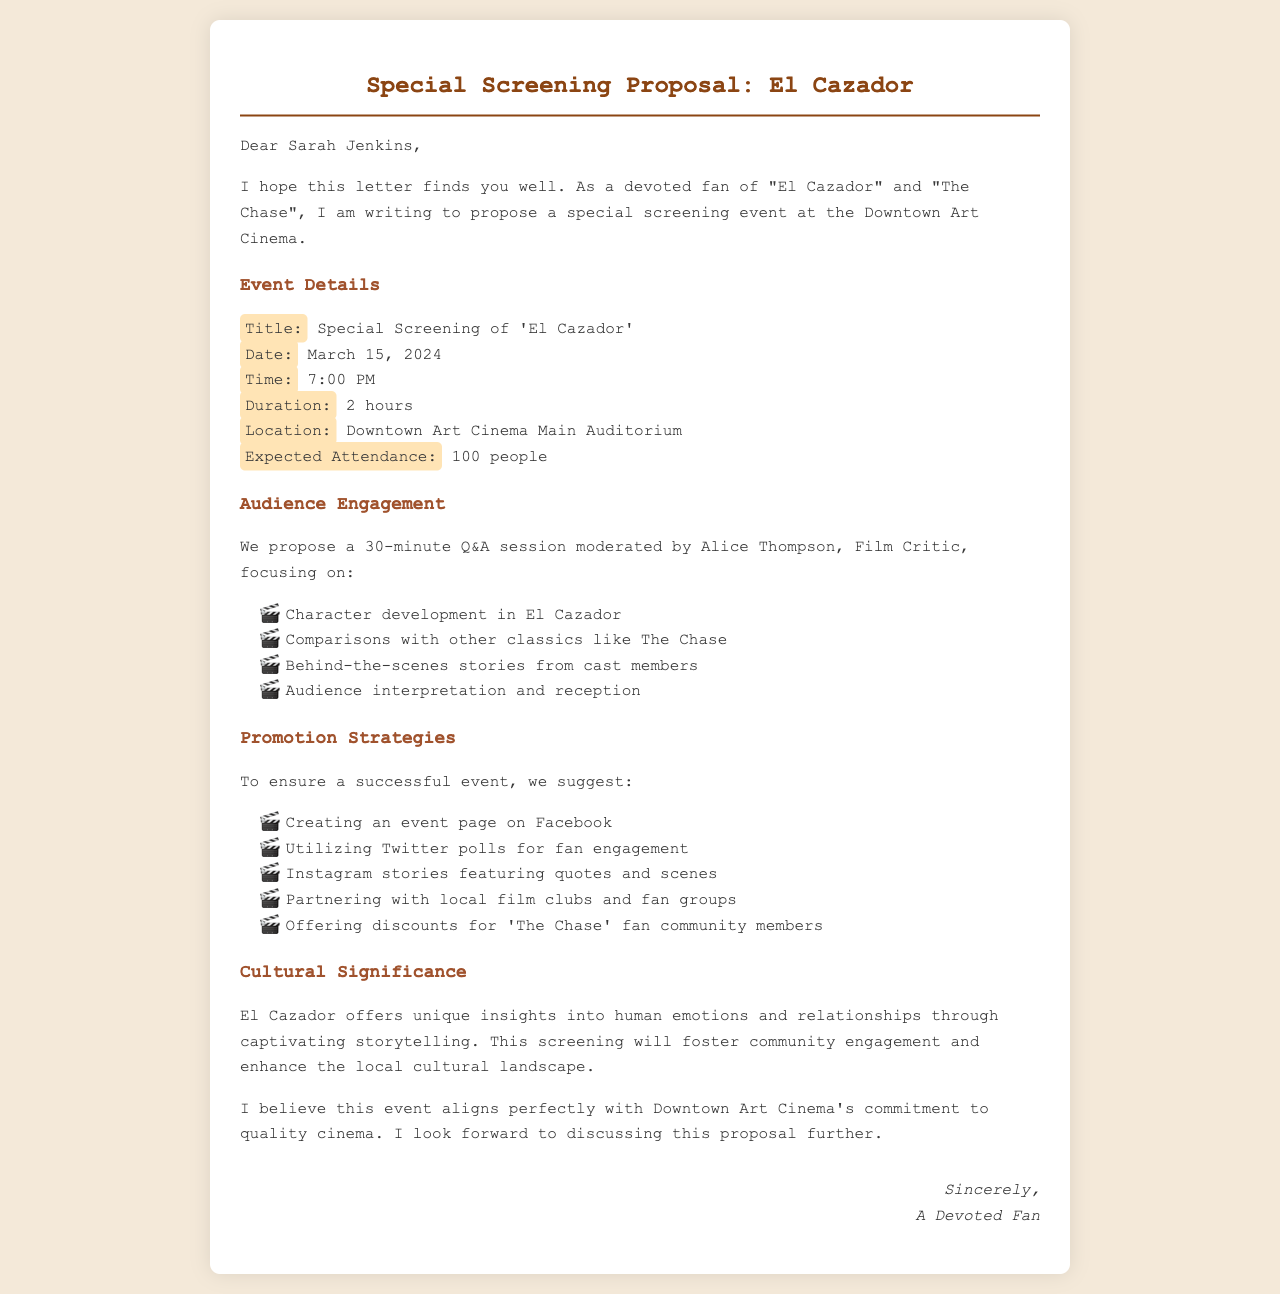What is the title of the event? The title of the event is mentioned in the document as "Special Screening of 'El Cazador'."
Answer: Special Screening of 'El Cazador' What is the date of the screening? The date of the event is specified in the proposal letter.
Answer: March 15, 2024 What is the duration of the film? The duration is indicated directly in the document as part of the event details.
Answer: 2 hours Who is moderating the Q&A session? The name of the moderator is stated in the audience engagement section.
Answer: Alice Thompson How long is the Q&A session? The duration of the Q&A session is explicitly mentioned in the proposal.
Answer: 30 minutes What is one method suggested for promoting the event? Promotion strategies in the document include various methods, one of which is explicitly mentioned.
Answer: Creating an event page on Facebook What is the expected attendance? The number of attendees expected at the screening is provided in the details section.
Answer: 100 people What significance does "El Cazador" hold according to the letter? The letter describes the cultural significance of "El Cazador."
Answer: Unique insights into human emotions and relationships What is the intended audience for the discounts? The discounts mentioned in the promotion strategies are specifically targeted at a group of fans.
Answer: 'The Chase' fan community members 